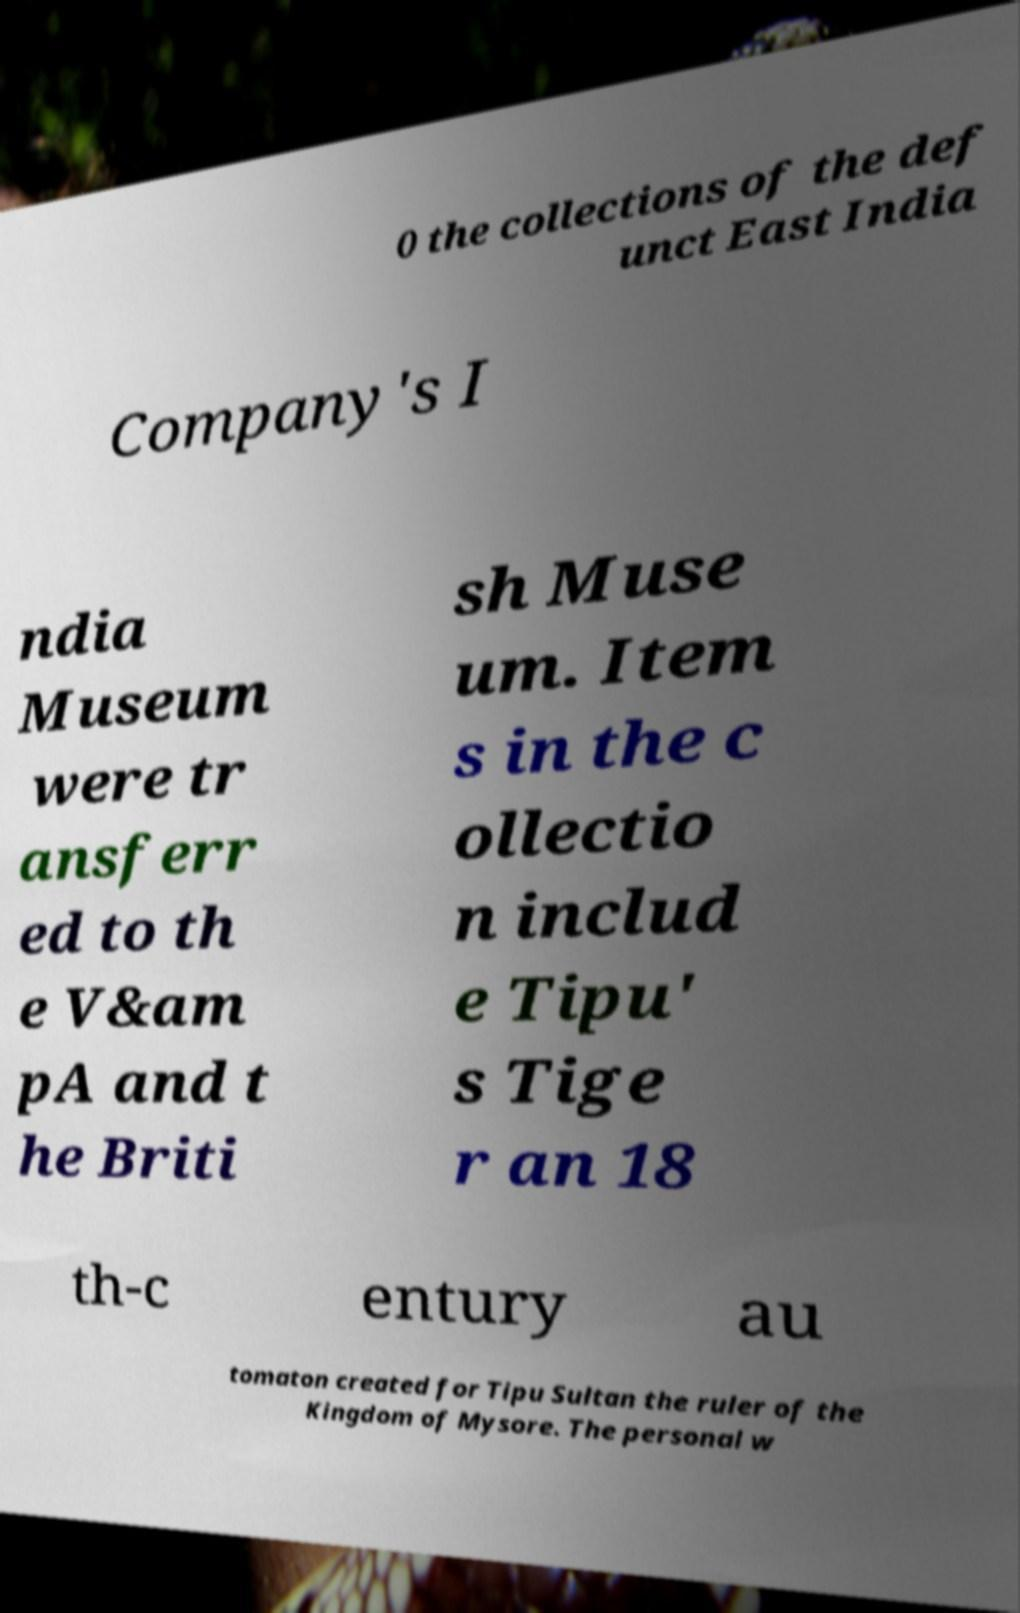Could you extract and type out the text from this image? 0 the collections of the def unct East India Company's I ndia Museum were tr ansferr ed to th e V&am pA and t he Briti sh Muse um. Item s in the c ollectio n includ e Tipu' s Tige r an 18 th-c entury au tomaton created for Tipu Sultan the ruler of the Kingdom of Mysore. The personal w 